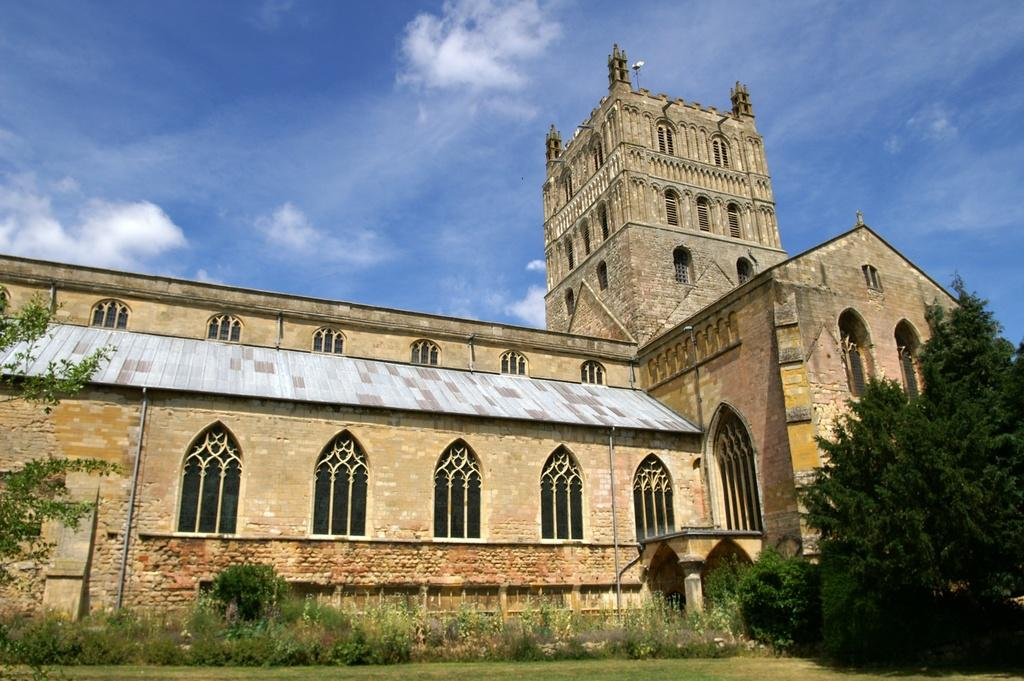What type of structure is present in the image? There is a building in the image. What can be seen in front of the building? There are trees and grass in front of the building. What is visible in the background of the image? There are clouds visible in the background of the image. What type of basket is being used by the beginner in the image? There is no basket or beginner present in the image. 